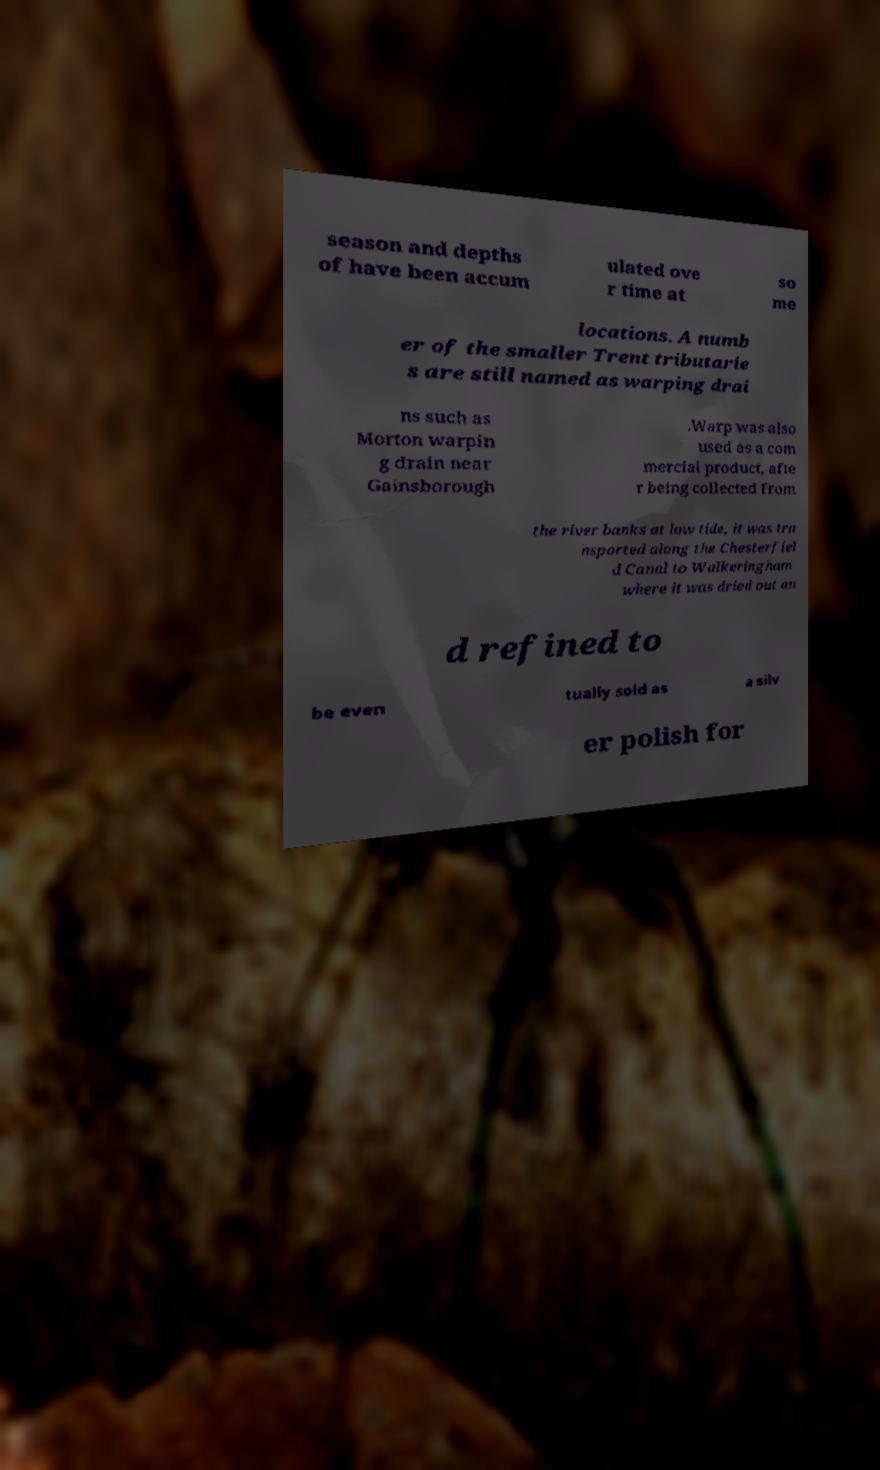Can you read and provide the text displayed in the image?This photo seems to have some interesting text. Can you extract and type it out for me? season and depths of have been accum ulated ove r time at so me locations. A numb er of the smaller Trent tributarie s are still named as warping drai ns such as Morton warpin g drain near Gainsborough .Warp was also used as a com mercial product, afte r being collected from the river banks at low tide, it was tra nsported along the Chesterfiel d Canal to Walkeringham where it was dried out an d refined to be even tually sold as a silv er polish for 